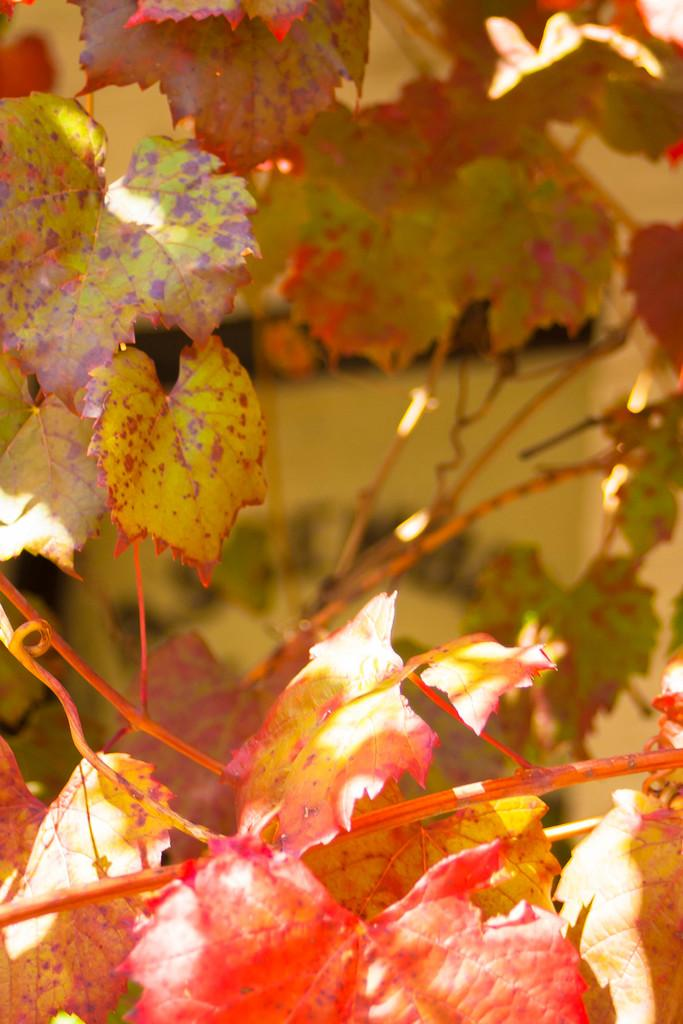What is the most noticeable feature of the plants in the image? The most noticeable feature of the plants in the image is the colorful leaves. Can you describe the background of the image? The background of the image is blurred. What advice does the grandmother give during the rainstorm in the image? There is no mention of a grandmother or a rainstorm in the image; it only features plants with colorful leaves and a blurred background. 